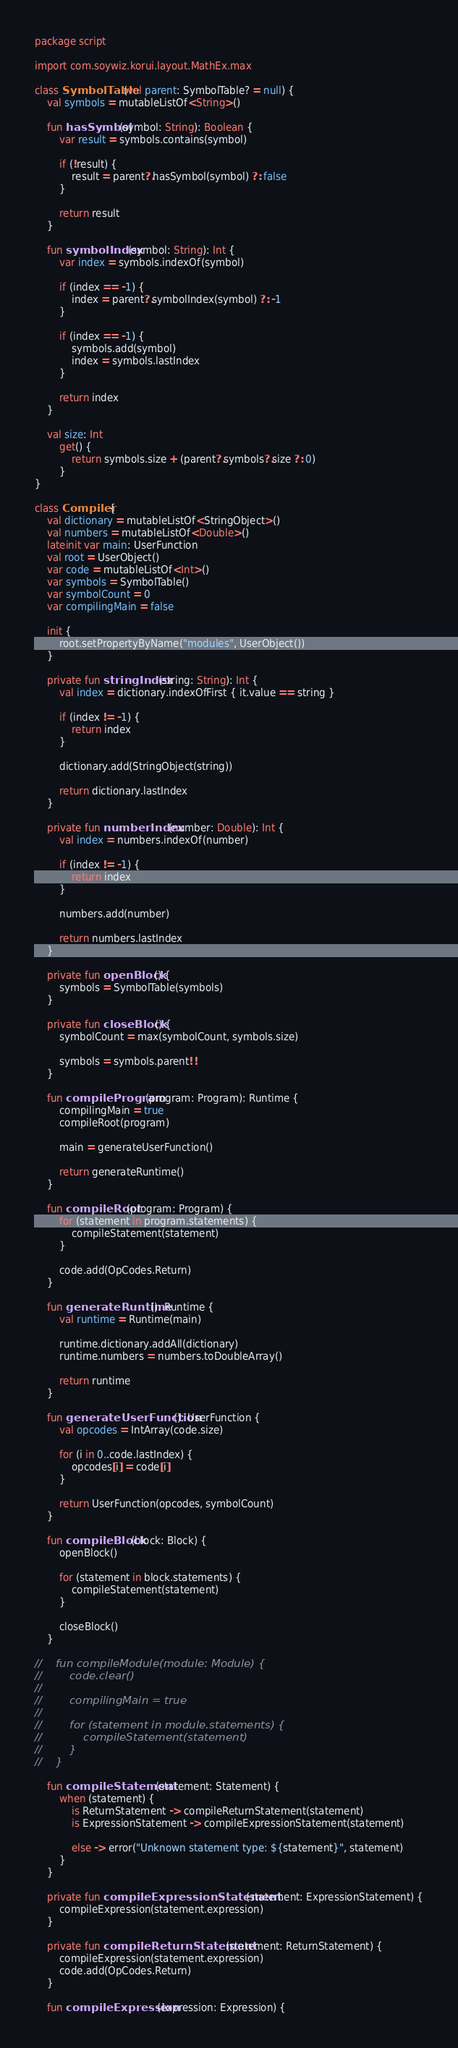Convert code to text. <code><loc_0><loc_0><loc_500><loc_500><_Kotlin_>package script

import com.soywiz.korui.layout.MathEx.max

class SymbolTable(val parent: SymbolTable? = null) {
    val symbols = mutableListOf<String>()

    fun hasSymbol(symbol: String): Boolean {
        var result = symbols.contains(symbol)

        if (!result) {
            result = parent?.hasSymbol(symbol) ?: false
        }

        return result
    }

    fun symbolIndex(symbol: String): Int {
        var index = symbols.indexOf(symbol)

        if (index == -1) {
            index = parent?.symbolIndex(symbol) ?: -1
        }

        if (index == -1) {
            symbols.add(symbol)
            index = symbols.lastIndex
        }

        return index
    }

    val size: Int
        get() {
            return symbols.size + (parent?.symbols?.size ?: 0)
        }
}

class Compiler {
    val dictionary = mutableListOf<StringObject>()
    val numbers = mutableListOf<Double>()
    lateinit var main: UserFunction
    val root = UserObject()
    var code = mutableListOf<Int>()
    var symbols = SymbolTable()
    var symbolCount = 0
    var compilingMain = false

    init {
        root.setPropertyByName("modules", UserObject())
    }

    private fun stringIndex(string: String): Int {
        val index = dictionary.indexOfFirst { it.value == string }

        if (index != -1) {
            return index
        }

        dictionary.add(StringObject(string))

        return dictionary.lastIndex
    }

    private fun numberIndex(number: Double): Int {
        val index = numbers.indexOf(number)

        if (index != -1) {
            return index
        }

        numbers.add(number)

        return numbers.lastIndex
    }

    private fun openBlock() {
        symbols = SymbolTable(symbols)
    }

    private fun closeBlock() {
        symbolCount = max(symbolCount, symbols.size)

        symbols = symbols.parent!!
    }

    fun compileProgram(program: Program): Runtime {
        compilingMain = true
        compileRoot(program)

        main = generateUserFunction()

        return generateRuntime()
    }

    fun compileRoot(program: Program) {
        for (statement in program.statements) {
            compileStatement(statement)
        }

        code.add(OpCodes.Return)
    }

    fun generateRuntime(): Runtime {
        val runtime = Runtime(main)

        runtime.dictionary.addAll(dictionary)
        runtime.numbers = numbers.toDoubleArray()

        return runtime
    }

    fun generateUserFunction(): UserFunction {
        val opcodes = IntArray(code.size)

        for (i in 0..code.lastIndex) {
            opcodes[i] = code[i]
        }

        return UserFunction(opcodes, symbolCount)
    }

    fun compileBlock(block: Block) {
        openBlock()

        for (statement in block.statements) {
            compileStatement(statement)
        }

        closeBlock()
    }

//    fun compileModule(module: Module) {
//        code.clear()
//
//        compilingMain = true
//
//        for (statement in module.statements) {
//            compileStatement(statement)
//        }
//    }

    fun compileStatement(statement: Statement) {
        when (statement) {
            is ReturnStatement -> compileReturnStatement(statement)
            is ExpressionStatement -> compileExpressionStatement(statement)

            else -> error("Unknown statement type: ${statement}", statement)
        }
    }

    private fun compileExpressionStatement(statement: ExpressionStatement) {
        compileExpression(statement.expression)
    }

    private fun compileReturnStatement(statement: ReturnStatement) {
        compileExpression(statement.expression)
        code.add(OpCodes.Return)
    }

    fun compileExpression(expression: Expression) {</code> 